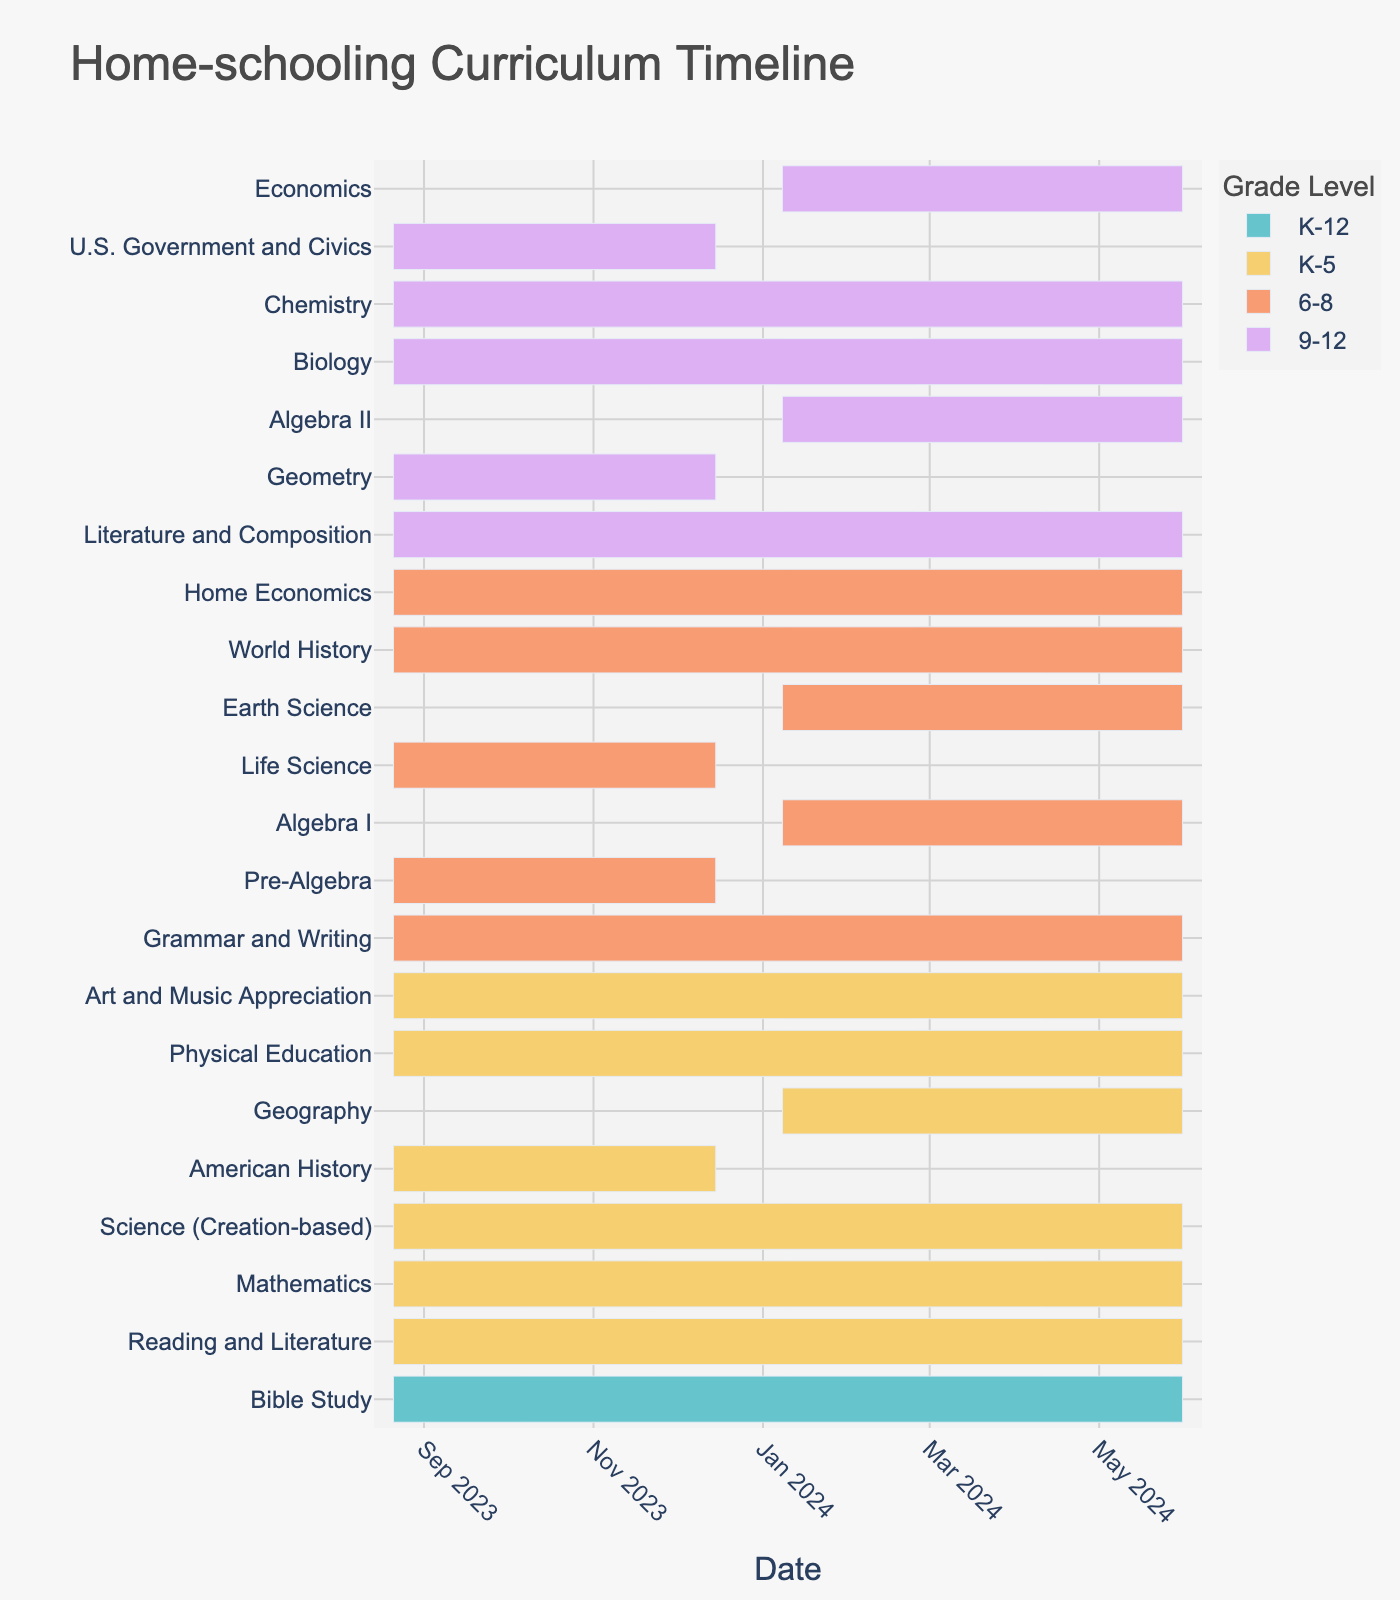What is the title of the figure? The title is typically located at the top of the figure and summarizes what the chart represents.
Answer: Home-schooling Curriculum Timeline Which subjects are taught throughout the entire school year for K-5? Simply look at the bars corresponding to each subject in the K-5 grade level to see which ones span from the start to the end of the school year.
Answer: Bible Study, Reading and Literature, Mathematics, Science (Creation-based), Physical Education, Art and Music Appreciation When does the Geography course for K-5 start and end? Find the bar that represents the Geography course for K-5. Identify its start and end points on the x-axis to determine the dates.
Answer: January 8, 2024, to May 31, 2024 What subjects are taught only in the first half of the year (before the new year) for 6-8? Identify the bars for the 6-8 grade level that end before January 1, 2024.
Answer: Pre-Algebra, Life Science Which high school math subjects are taught, and during which semesters do they occur? Identify the bars corresponding to the 9-12 grade level and the math subjects (Geometry, Algebra II). Check the dates associated with these bars.
Answer: Geometry (Aug 21, 2023, to Dec 15, 2023), Algebra II (Jan 8, 2024, to May 31, 2024) Which subjects have different start dates for 6-8 and 9-12 grades? Compare the start dates of subjects taught across 6-8 and 9-12 grade levels to identify any differences.
Answer: Algebra (Pre-Algebra and Algebra I) and Science (Life Science and Earth Science) Which subject for 9-12 spans the entire school year? Locate the bars for the 9-12 grade level subjects and identify the one that starts at the beginning and ends at the end of the timeline.
Answer: Biology, Chemistry, Literature and Composition How many subjects are there in total for each grade group (K-5, 6-8, 9-12)? Count the number of unique subjects for each grade level category.
Answer: K-5: 8 subjects, 6-8: 7 subjects, 9-12: 7 subjects What is the duration of the Economics course for 9-12 students? Locate the bar for the Economics course for the 9-12 grade level and calculate the difference between the start and end dates.
Answer: January 8, 2024, to May 31, 2024 (approximately 5 months) Which grade level has the most subjects starting after the New Year? Count the subjects for each grade level that start after January 1, 2024, and compare the counts.
Answer: 6-8 grade level has 2 subjects starting after the New Year (Algebra I, Earth Science) 